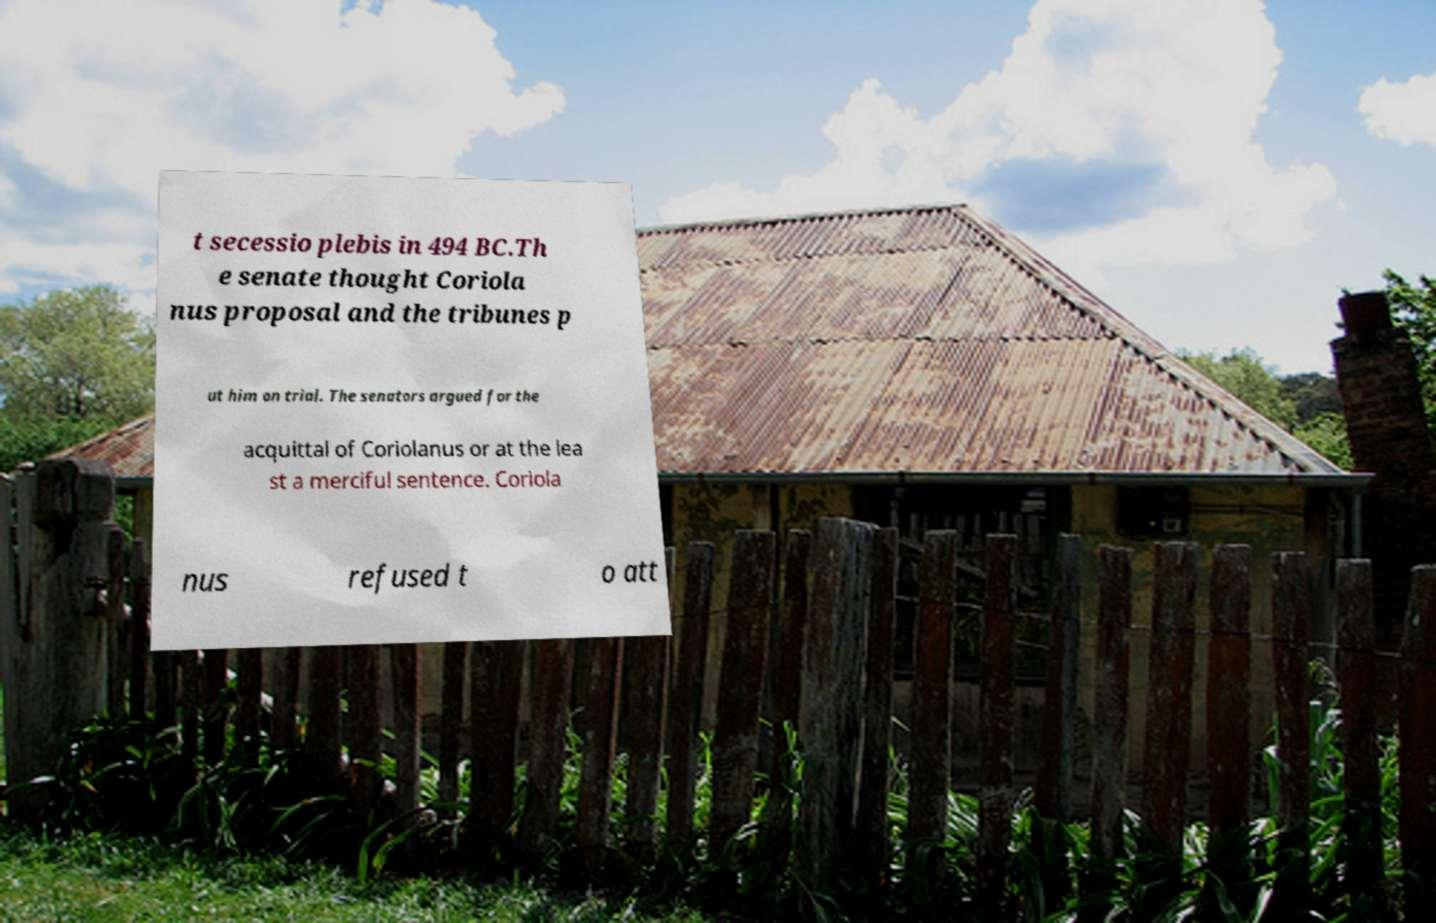Please read and relay the text visible in this image. What does it say? t secessio plebis in 494 BC.Th e senate thought Coriola nus proposal and the tribunes p ut him on trial. The senators argued for the acquittal of Coriolanus or at the lea st a merciful sentence. Coriola nus refused t o att 